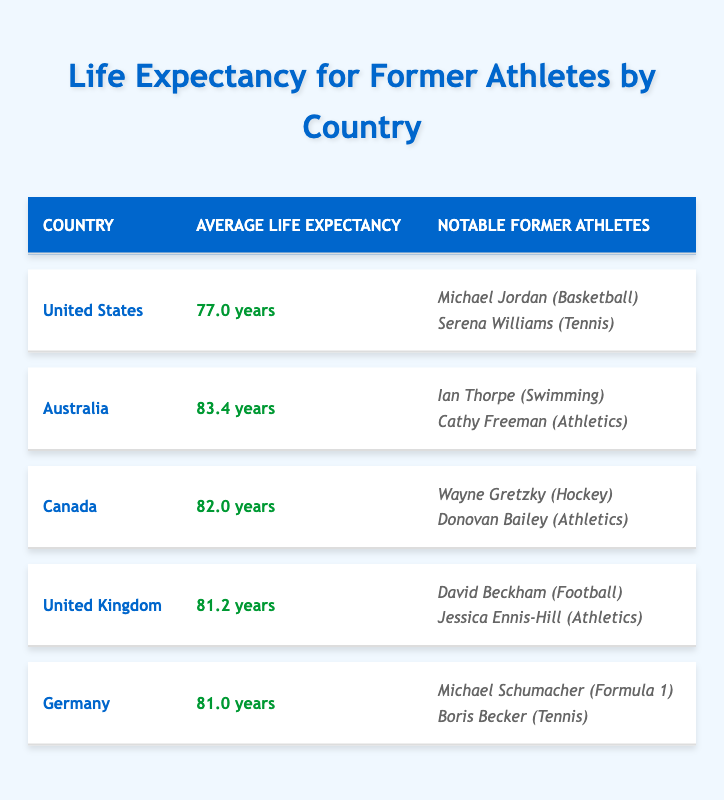What is the average life expectancy in Australia? The table lists Australia under the country column with an average life expectancy of 83.4 years mentioned in the corresponding row.
Answer: 83.4 years Which country has the highest average life expectancy? By reviewing the average life expectancy values in the table, Australia has the highest value at 83.4 years compared to United States, Canada, United Kingdom, and Germany.
Answer: Australia Is Michael Jordan a notable former athlete in the United Kingdom? The table shows Michael Jordan listed under the United States as a notable former athlete. Since he is not mentioned in the United Kingdom section, the answer is no.
Answer: No What is the difference in average life expectancy between Canada and Germany? Canada has an average life expectancy of 82.0 years, while Germany has 81.0 years. The difference is calculated as 82.0 - 81.0 = 1.0 years.
Answer: 1.0 years How many notable former athletes from the United States are listed in the table? The table indicates that there are two notable former athletes from the United States: Michael Jordan and Serena Williams. Counting them gives a total of two athletes.
Answer: 2 Which sport does Cathy Freeman play? The table lists Cathy Freeman as a notable former athlete under Australia, with her corresponding sport noted as Athletics.
Answer: Athletics If you were to average the life expectancies of Canada and the United Kingdom, what would that average be? Canada has an average life expectancy of 82.0 years and the United Kingdom has 81.2 years. The average is calculated as (82.0 + 81.2) / 2 = 81.6 years.
Answer: 81.6 years Is there a notable former athlete from Germany who participated in Formula 1? The table lists Michael Schumacher, a notable former athlete from Germany who participated in Formula 1, confirming that the statement is true.
Answer: Yes Which country has a lower average life expectancy, the United States or Germany? The average life expectancy for the United States is 77.0 years, while Germany's is 81.0 years. Hence, the United States has the lower average life expectancy.
Answer: United States 